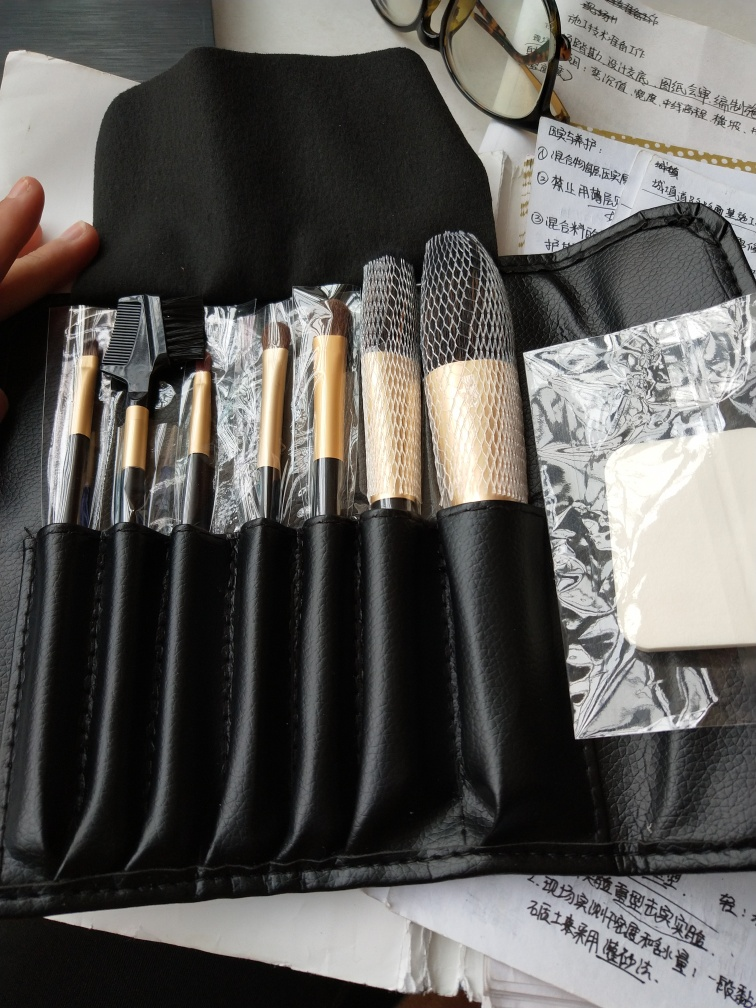Can you tell me what items are visible in this image? The image shows a collection of makeup brushes with various brush head sizes and shapes, designed for different applications. They are neatly arranged in a roll-up case with transparent plastic covers protecting the bristles. There's also a spectacle case adjacent to the brushes, and under the case are some papers with printed text that appears to be in Chinese. 